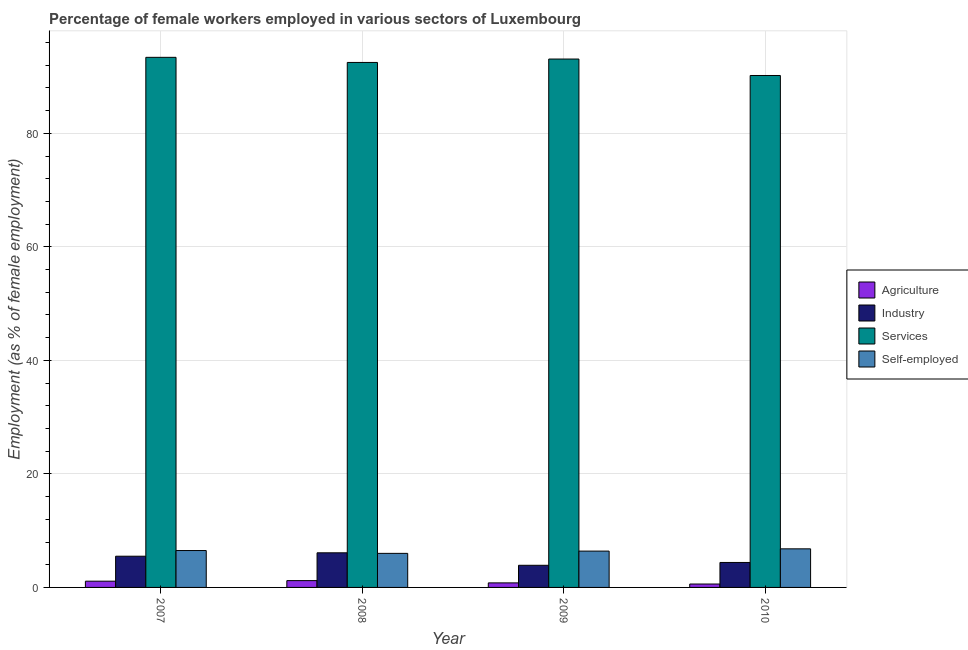Are the number of bars on each tick of the X-axis equal?
Provide a short and direct response. Yes. How many bars are there on the 1st tick from the left?
Ensure brevity in your answer.  4. How many bars are there on the 3rd tick from the right?
Your answer should be very brief. 4. In how many cases, is the number of bars for a given year not equal to the number of legend labels?
Your answer should be compact. 0. What is the percentage of female workers in industry in 2008?
Offer a terse response. 6.1. Across all years, what is the maximum percentage of female workers in industry?
Keep it short and to the point. 6.1. In which year was the percentage of female workers in industry minimum?
Ensure brevity in your answer.  2009. What is the total percentage of self employed female workers in the graph?
Your answer should be very brief. 25.7. What is the difference between the percentage of female workers in services in 2008 and that in 2010?
Offer a very short reply. 2.3. What is the difference between the percentage of female workers in industry in 2008 and the percentage of self employed female workers in 2007?
Ensure brevity in your answer.  0.6. What is the average percentage of female workers in industry per year?
Offer a very short reply. 4.98. In how many years, is the percentage of female workers in industry greater than 52 %?
Ensure brevity in your answer.  0. What is the ratio of the percentage of female workers in industry in 2008 to that in 2010?
Give a very brief answer. 1.39. What is the difference between the highest and the second highest percentage of self employed female workers?
Provide a succinct answer. 0.3. What is the difference between the highest and the lowest percentage of female workers in industry?
Your answer should be very brief. 2.2. Is the sum of the percentage of female workers in industry in 2007 and 2008 greater than the maximum percentage of female workers in agriculture across all years?
Your response must be concise. Yes. What does the 3rd bar from the left in 2009 represents?
Provide a short and direct response. Services. What does the 4th bar from the right in 2010 represents?
Provide a short and direct response. Agriculture. Is it the case that in every year, the sum of the percentage of female workers in agriculture and percentage of female workers in industry is greater than the percentage of female workers in services?
Ensure brevity in your answer.  No. Are all the bars in the graph horizontal?
Your answer should be very brief. No. Does the graph contain any zero values?
Provide a short and direct response. No. Does the graph contain grids?
Give a very brief answer. Yes. How many legend labels are there?
Your answer should be very brief. 4. How are the legend labels stacked?
Provide a short and direct response. Vertical. What is the title of the graph?
Your response must be concise. Percentage of female workers employed in various sectors of Luxembourg. Does "HFC gas" appear as one of the legend labels in the graph?
Provide a succinct answer. No. What is the label or title of the X-axis?
Offer a very short reply. Year. What is the label or title of the Y-axis?
Give a very brief answer. Employment (as % of female employment). What is the Employment (as % of female employment) in Agriculture in 2007?
Your answer should be compact. 1.1. What is the Employment (as % of female employment) in Services in 2007?
Your answer should be very brief. 93.4. What is the Employment (as % of female employment) in Self-employed in 2007?
Make the answer very short. 6.5. What is the Employment (as % of female employment) in Agriculture in 2008?
Your answer should be compact. 1.2. What is the Employment (as % of female employment) of Industry in 2008?
Offer a very short reply. 6.1. What is the Employment (as % of female employment) of Services in 2008?
Provide a short and direct response. 92.5. What is the Employment (as % of female employment) in Self-employed in 2008?
Give a very brief answer. 6. What is the Employment (as % of female employment) of Agriculture in 2009?
Ensure brevity in your answer.  0.8. What is the Employment (as % of female employment) in Industry in 2009?
Ensure brevity in your answer.  3.9. What is the Employment (as % of female employment) of Services in 2009?
Make the answer very short. 93.1. What is the Employment (as % of female employment) in Self-employed in 2009?
Provide a short and direct response. 6.4. What is the Employment (as % of female employment) in Agriculture in 2010?
Ensure brevity in your answer.  0.6. What is the Employment (as % of female employment) of Industry in 2010?
Offer a very short reply. 4.4. What is the Employment (as % of female employment) in Services in 2010?
Your answer should be very brief. 90.2. What is the Employment (as % of female employment) of Self-employed in 2010?
Provide a succinct answer. 6.8. Across all years, what is the maximum Employment (as % of female employment) in Agriculture?
Keep it short and to the point. 1.2. Across all years, what is the maximum Employment (as % of female employment) of Industry?
Offer a terse response. 6.1. Across all years, what is the maximum Employment (as % of female employment) in Services?
Your response must be concise. 93.4. Across all years, what is the maximum Employment (as % of female employment) in Self-employed?
Give a very brief answer. 6.8. Across all years, what is the minimum Employment (as % of female employment) in Agriculture?
Offer a very short reply. 0.6. Across all years, what is the minimum Employment (as % of female employment) of Industry?
Offer a terse response. 3.9. Across all years, what is the minimum Employment (as % of female employment) of Services?
Your answer should be compact. 90.2. Across all years, what is the minimum Employment (as % of female employment) in Self-employed?
Keep it short and to the point. 6. What is the total Employment (as % of female employment) of Agriculture in the graph?
Your answer should be compact. 3.7. What is the total Employment (as % of female employment) of Industry in the graph?
Offer a terse response. 19.9. What is the total Employment (as % of female employment) in Services in the graph?
Offer a terse response. 369.2. What is the total Employment (as % of female employment) of Self-employed in the graph?
Keep it short and to the point. 25.7. What is the difference between the Employment (as % of female employment) in Agriculture in 2007 and that in 2008?
Give a very brief answer. -0.1. What is the difference between the Employment (as % of female employment) of Industry in 2007 and that in 2009?
Provide a succinct answer. 1.6. What is the difference between the Employment (as % of female employment) of Services in 2007 and that in 2009?
Offer a very short reply. 0.3. What is the difference between the Employment (as % of female employment) in Agriculture in 2007 and that in 2010?
Offer a very short reply. 0.5. What is the difference between the Employment (as % of female employment) in Industry in 2007 and that in 2010?
Ensure brevity in your answer.  1.1. What is the difference between the Employment (as % of female employment) of Services in 2007 and that in 2010?
Your answer should be very brief. 3.2. What is the difference between the Employment (as % of female employment) of Agriculture in 2008 and that in 2009?
Ensure brevity in your answer.  0.4. What is the difference between the Employment (as % of female employment) of Industry in 2008 and that in 2009?
Your answer should be compact. 2.2. What is the difference between the Employment (as % of female employment) in Services in 2008 and that in 2009?
Offer a very short reply. -0.6. What is the difference between the Employment (as % of female employment) of Self-employed in 2008 and that in 2009?
Ensure brevity in your answer.  -0.4. What is the difference between the Employment (as % of female employment) in Industry in 2008 and that in 2010?
Offer a very short reply. 1.7. What is the difference between the Employment (as % of female employment) in Agriculture in 2009 and that in 2010?
Keep it short and to the point. 0.2. What is the difference between the Employment (as % of female employment) of Self-employed in 2009 and that in 2010?
Give a very brief answer. -0.4. What is the difference between the Employment (as % of female employment) of Agriculture in 2007 and the Employment (as % of female employment) of Services in 2008?
Offer a very short reply. -91.4. What is the difference between the Employment (as % of female employment) of Agriculture in 2007 and the Employment (as % of female employment) of Self-employed in 2008?
Keep it short and to the point. -4.9. What is the difference between the Employment (as % of female employment) of Industry in 2007 and the Employment (as % of female employment) of Services in 2008?
Keep it short and to the point. -87. What is the difference between the Employment (as % of female employment) in Industry in 2007 and the Employment (as % of female employment) in Self-employed in 2008?
Ensure brevity in your answer.  -0.5. What is the difference between the Employment (as % of female employment) in Services in 2007 and the Employment (as % of female employment) in Self-employed in 2008?
Keep it short and to the point. 87.4. What is the difference between the Employment (as % of female employment) of Agriculture in 2007 and the Employment (as % of female employment) of Industry in 2009?
Your answer should be compact. -2.8. What is the difference between the Employment (as % of female employment) of Agriculture in 2007 and the Employment (as % of female employment) of Services in 2009?
Offer a terse response. -92. What is the difference between the Employment (as % of female employment) of Agriculture in 2007 and the Employment (as % of female employment) of Self-employed in 2009?
Offer a terse response. -5.3. What is the difference between the Employment (as % of female employment) in Industry in 2007 and the Employment (as % of female employment) in Services in 2009?
Provide a short and direct response. -87.6. What is the difference between the Employment (as % of female employment) of Services in 2007 and the Employment (as % of female employment) of Self-employed in 2009?
Keep it short and to the point. 87. What is the difference between the Employment (as % of female employment) of Agriculture in 2007 and the Employment (as % of female employment) of Industry in 2010?
Provide a short and direct response. -3.3. What is the difference between the Employment (as % of female employment) in Agriculture in 2007 and the Employment (as % of female employment) in Services in 2010?
Keep it short and to the point. -89.1. What is the difference between the Employment (as % of female employment) in Industry in 2007 and the Employment (as % of female employment) in Services in 2010?
Your response must be concise. -84.7. What is the difference between the Employment (as % of female employment) in Industry in 2007 and the Employment (as % of female employment) in Self-employed in 2010?
Keep it short and to the point. -1.3. What is the difference between the Employment (as % of female employment) in Services in 2007 and the Employment (as % of female employment) in Self-employed in 2010?
Your answer should be very brief. 86.6. What is the difference between the Employment (as % of female employment) of Agriculture in 2008 and the Employment (as % of female employment) of Services in 2009?
Your answer should be very brief. -91.9. What is the difference between the Employment (as % of female employment) of Industry in 2008 and the Employment (as % of female employment) of Services in 2009?
Keep it short and to the point. -87. What is the difference between the Employment (as % of female employment) in Services in 2008 and the Employment (as % of female employment) in Self-employed in 2009?
Offer a very short reply. 86.1. What is the difference between the Employment (as % of female employment) of Agriculture in 2008 and the Employment (as % of female employment) of Services in 2010?
Your response must be concise. -89. What is the difference between the Employment (as % of female employment) in Industry in 2008 and the Employment (as % of female employment) in Services in 2010?
Make the answer very short. -84.1. What is the difference between the Employment (as % of female employment) of Services in 2008 and the Employment (as % of female employment) of Self-employed in 2010?
Offer a very short reply. 85.7. What is the difference between the Employment (as % of female employment) of Agriculture in 2009 and the Employment (as % of female employment) of Services in 2010?
Give a very brief answer. -89.4. What is the difference between the Employment (as % of female employment) of Industry in 2009 and the Employment (as % of female employment) of Services in 2010?
Give a very brief answer. -86.3. What is the difference between the Employment (as % of female employment) of Industry in 2009 and the Employment (as % of female employment) of Self-employed in 2010?
Provide a succinct answer. -2.9. What is the difference between the Employment (as % of female employment) in Services in 2009 and the Employment (as % of female employment) in Self-employed in 2010?
Make the answer very short. 86.3. What is the average Employment (as % of female employment) of Agriculture per year?
Keep it short and to the point. 0.93. What is the average Employment (as % of female employment) of Industry per year?
Offer a terse response. 4.97. What is the average Employment (as % of female employment) in Services per year?
Make the answer very short. 92.3. What is the average Employment (as % of female employment) of Self-employed per year?
Make the answer very short. 6.42. In the year 2007, what is the difference between the Employment (as % of female employment) of Agriculture and Employment (as % of female employment) of Services?
Your response must be concise. -92.3. In the year 2007, what is the difference between the Employment (as % of female employment) of Industry and Employment (as % of female employment) of Services?
Keep it short and to the point. -87.9. In the year 2007, what is the difference between the Employment (as % of female employment) in Industry and Employment (as % of female employment) in Self-employed?
Offer a terse response. -1. In the year 2007, what is the difference between the Employment (as % of female employment) in Services and Employment (as % of female employment) in Self-employed?
Your response must be concise. 86.9. In the year 2008, what is the difference between the Employment (as % of female employment) in Agriculture and Employment (as % of female employment) in Industry?
Make the answer very short. -4.9. In the year 2008, what is the difference between the Employment (as % of female employment) of Agriculture and Employment (as % of female employment) of Services?
Offer a terse response. -91.3. In the year 2008, what is the difference between the Employment (as % of female employment) of Industry and Employment (as % of female employment) of Services?
Your response must be concise. -86.4. In the year 2008, what is the difference between the Employment (as % of female employment) of Industry and Employment (as % of female employment) of Self-employed?
Offer a terse response. 0.1. In the year 2008, what is the difference between the Employment (as % of female employment) in Services and Employment (as % of female employment) in Self-employed?
Ensure brevity in your answer.  86.5. In the year 2009, what is the difference between the Employment (as % of female employment) of Agriculture and Employment (as % of female employment) of Services?
Your response must be concise. -92.3. In the year 2009, what is the difference between the Employment (as % of female employment) in Industry and Employment (as % of female employment) in Services?
Make the answer very short. -89.2. In the year 2009, what is the difference between the Employment (as % of female employment) in Industry and Employment (as % of female employment) in Self-employed?
Provide a succinct answer. -2.5. In the year 2009, what is the difference between the Employment (as % of female employment) in Services and Employment (as % of female employment) in Self-employed?
Give a very brief answer. 86.7. In the year 2010, what is the difference between the Employment (as % of female employment) of Agriculture and Employment (as % of female employment) of Services?
Provide a short and direct response. -89.6. In the year 2010, what is the difference between the Employment (as % of female employment) in Agriculture and Employment (as % of female employment) in Self-employed?
Provide a succinct answer. -6.2. In the year 2010, what is the difference between the Employment (as % of female employment) in Industry and Employment (as % of female employment) in Services?
Offer a terse response. -85.8. In the year 2010, what is the difference between the Employment (as % of female employment) in Services and Employment (as % of female employment) in Self-employed?
Give a very brief answer. 83.4. What is the ratio of the Employment (as % of female employment) of Industry in 2007 to that in 2008?
Make the answer very short. 0.9. What is the ratio of the Employment (as % of female employment) of Services in 2007 to that in 2008?
Offer a very short reply. 1.01. What is the ratio of the Employment (as % of female employment) of Agriculture in 2007 to that in 2009?
Offer a terse response. 1.38. What is the ratio of the Employment (as % of female employment) in Industry in 2007 to that in 2009?
Offer a terse response. 1.41. What is the ratio of the Employment (as % of female employment) in Services in 2007 to that in 2009?
Your answer should be very brief. 1. What is the ratio of the Employment (as % of female employment) of Self-employed in 2007 to that in 2009?
Your answer should be compact. 1.02. What is the ratio of the Employment (as % of female employment) of Agriculture in 2007 to that in 2010?
Your answer should be very brief. 1.83. What is the ratio of the Employment (as % of female employment) of Industry in 2007 to that in 2010?
Your response must be concise. 1.25. What is the ratio of the Employment (as % of female employment) in Services in 2007 to that in 2010?
Your answer should be compact. 1.04. What is the ratio of the Employment (as % of female employment) in Self-employed in 2007 to that in 2010?
Give a very brief answer. 0.96. What is the ratio of the Employment (as % of female employment) in Agriculture in 2008 to that in 2009?
Provide a short and direct response. 1.5. What is the ratio of the Employment (as % of female employment) in Industry in 2008 to that in 2009?
Offer a terse response. 1.56. What is the ratio of the Employment (as % of female employment) of Agriculture in 2008 to that in 2010?
Provide a short and direct response. 2. What is the ratio of the Employment (as % of female employment) of Industry in 2008 to that in 2010?
Make the answer very short. 1.39. What is the ratio of the Employment (as % of female employment) in Services in 2008 to that in 2010?
Provide a short and direct response. 1.03. What is the ratio of the Employment (as % of female employment) of Self-employed in 2008 to that in 2010?
Your answer should be very brief. 0.88. What is the ratio of the Employment (as % of female employment) of Agriculture in 2009 to that in 2010?
Offer a terse response. 1.33. What is the ratio of the Employment (as % of female employment) in Industry in 2009 to that in 2010?
Your answer should be compact. 0.89. What is the ratio of the Employment (as % of female employment) in Services in 2009 to that in 2010?
Offer a terse response. 1.03. What is the ratio of the Employment (as % of female employment) in Self-employed in 2009 to that in 2010?
Keep it short and to the point. 0.94. What is the difference between the highest and the second highest Employment (as % of female employment) of Agriculture?
Ensure brevity in your answer.  0.1. What is the difference between the highest and the second highest Employment (as % of female employment) of Self-employed?
Ensure brevity in your answer.  0.3. What is the difference between the highest and the lowest Employment (as % of female employment) of Agriculture?
Keep it short and to the point. 0.6. 